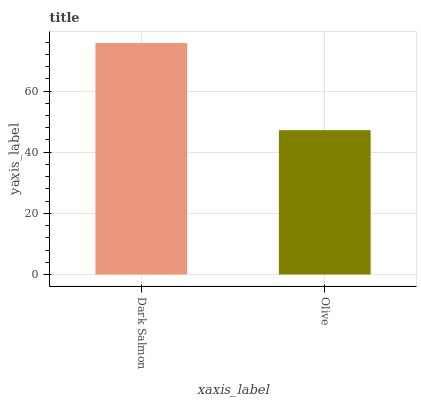Is Olive the minimum?
Answer yes or no. Yes. Is Dark Salmon the maximum?
Answer yes or no. Yes. Is Olive the maximum?
Answer yes or no. No. Is Dark Salmon greater than Olive?
Answer yes or no. Yes. Is Olive less than Dark Salmon?
Answer yes or no. Yes. Is Olive greater than Dark Salmon?
Answer yes or no. No. Is Dark Salmon less than Olive?
Answer yes or no. No. Is Dark Salmon the high median?
Answer yes or no. Yes. Is Olive the low median?
Answer yes or no. Yes. Is Olive the high median?
Answer yes or no. No. Is Dark Salmon the low median?
Answer yes or no. No. 